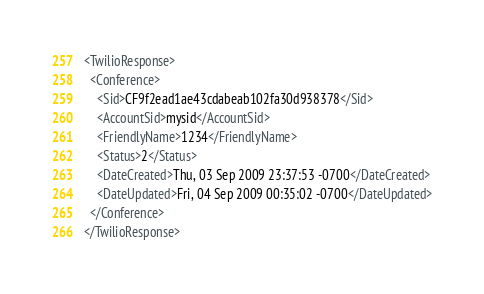Convert code to text. <code><loc_0><loc_0><loc_500><loc_500><_XML_><TwilioResponse>
  <Conference>
    <Sid>CF9f2ead1ae43cdabeab102fa30d938378</Sid>
    <AccountSid>mysid</AccountSid>
    <FriendlyName>1234</FriendlyName>
    <Status>2</Status>
    <DateCreated>Thu, 03 Sep 2009 23:37:53 -0700</DateCreated>
    <DateUpdated>Fri, 04 Sep 2009 00:35:02 -0700</DateUpdated>
  </Conference>
</TwilioResponse></code> 